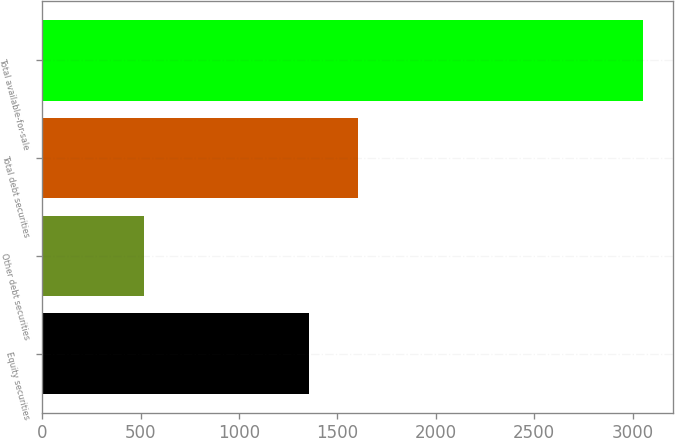Convert chart. <chart><loc_0><loc_0><loc_500><loc_500><bar_chart><fcel>Equity securities<fcel>Other debt securities<fcel>Total debt securities<fcel>Total available-for-sale<nl><fcel>1353<fcel>516<fcel>1606.7<fcel>3053<nl></chart> 